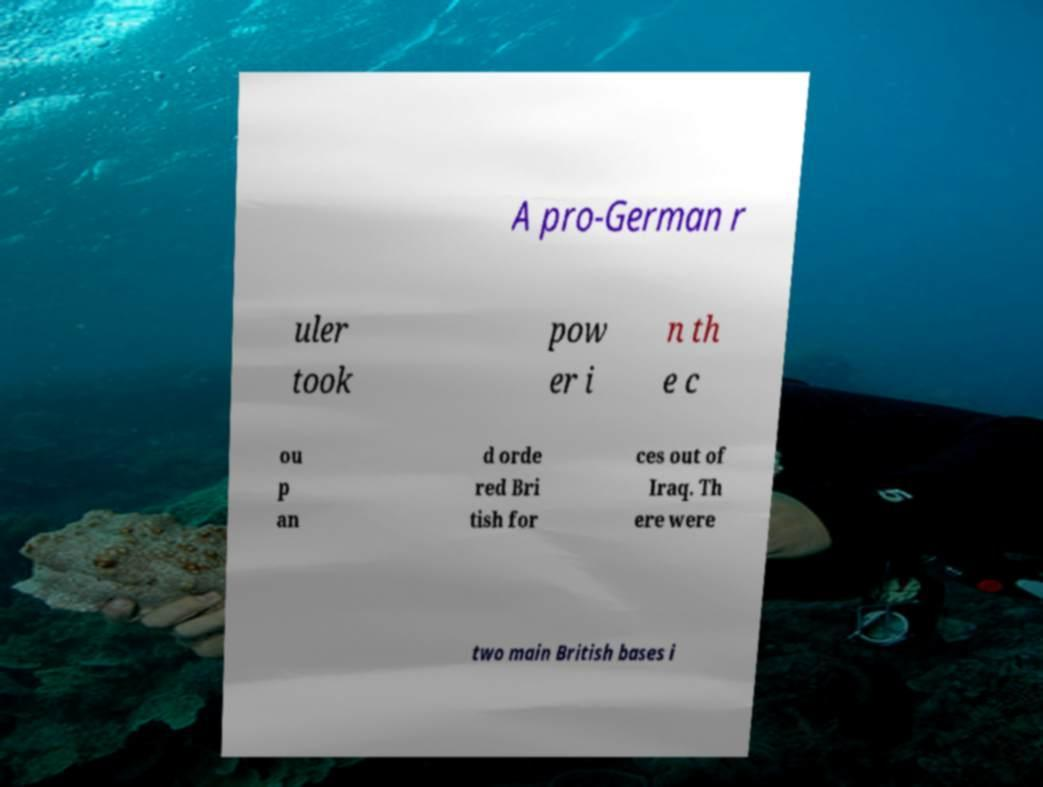I need the written content from this picture converted into text. Can you do that? A pro-German r uler took pow er i n th e c ou p an d orde red Bri tish for ces out of Iraq. Th ere were two main British bases i 